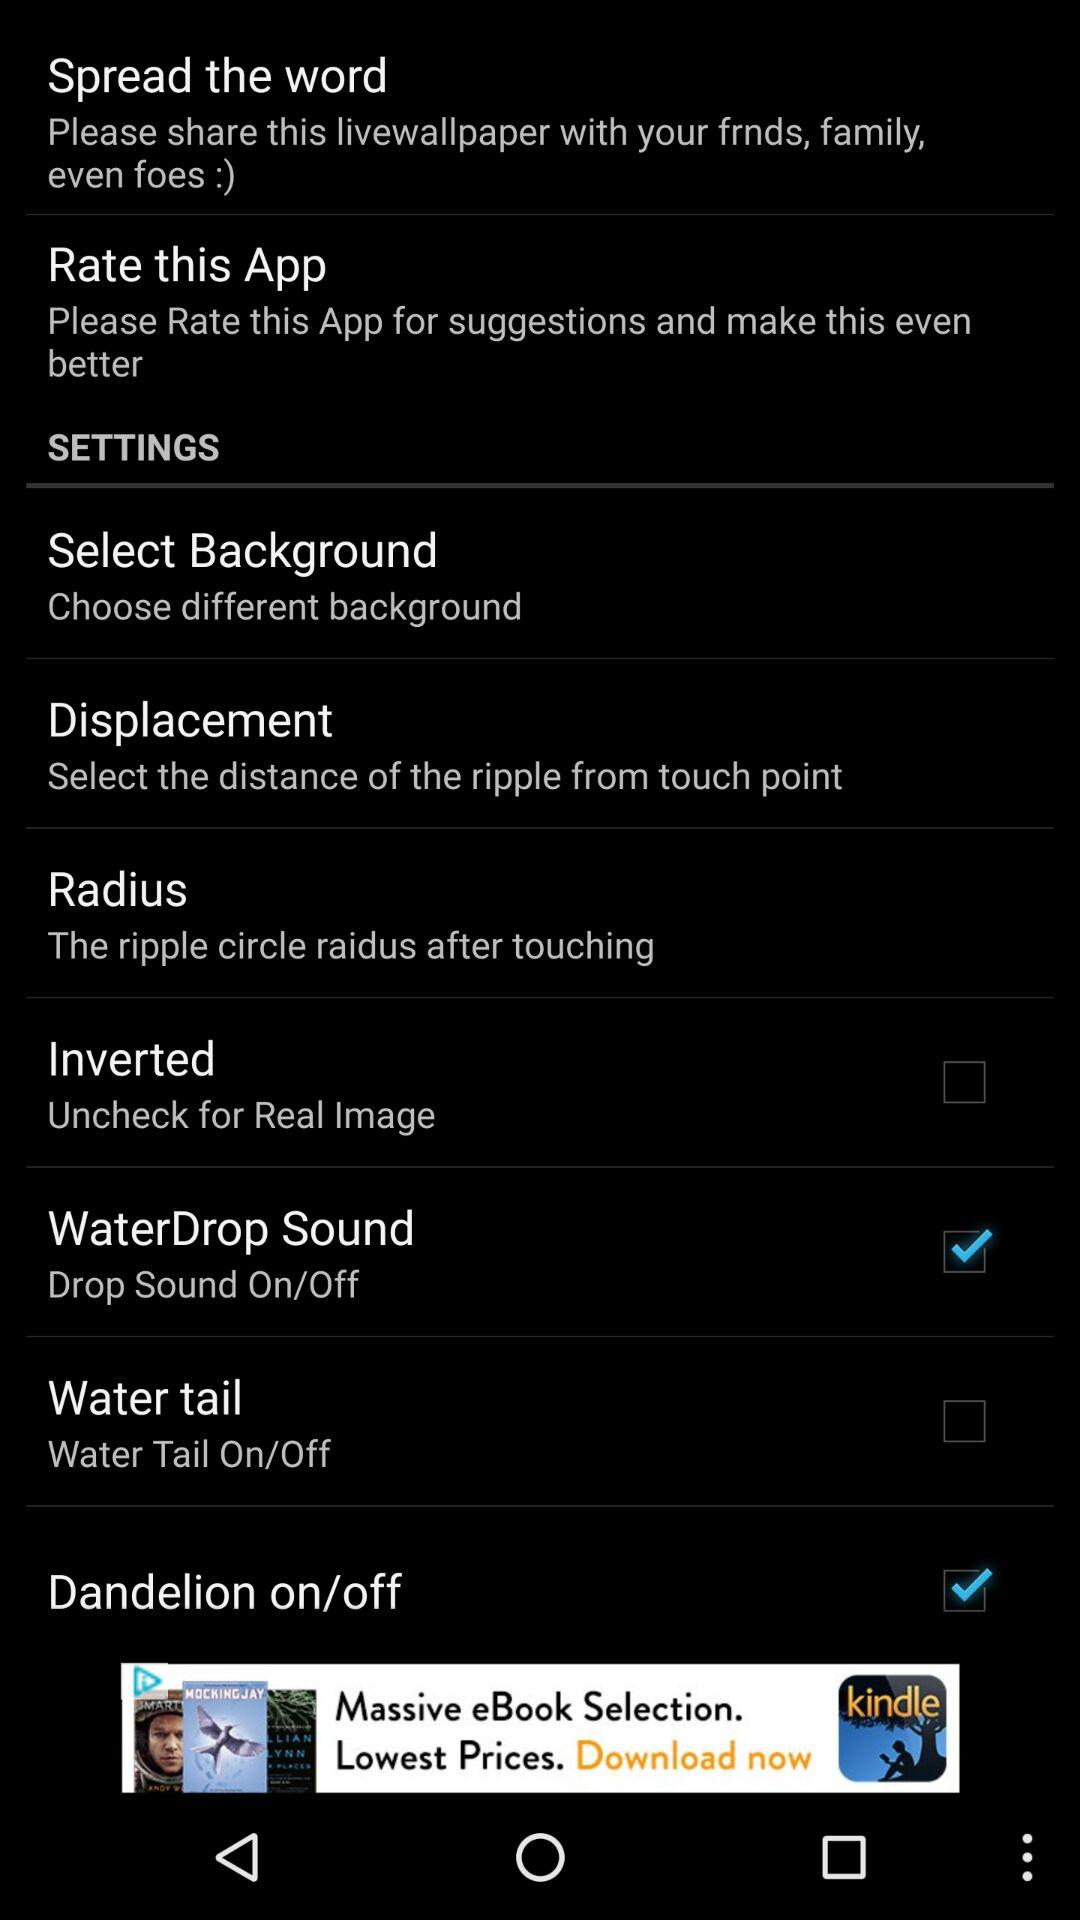What is the status of "WaterDrop Sound"? The status is "on". 